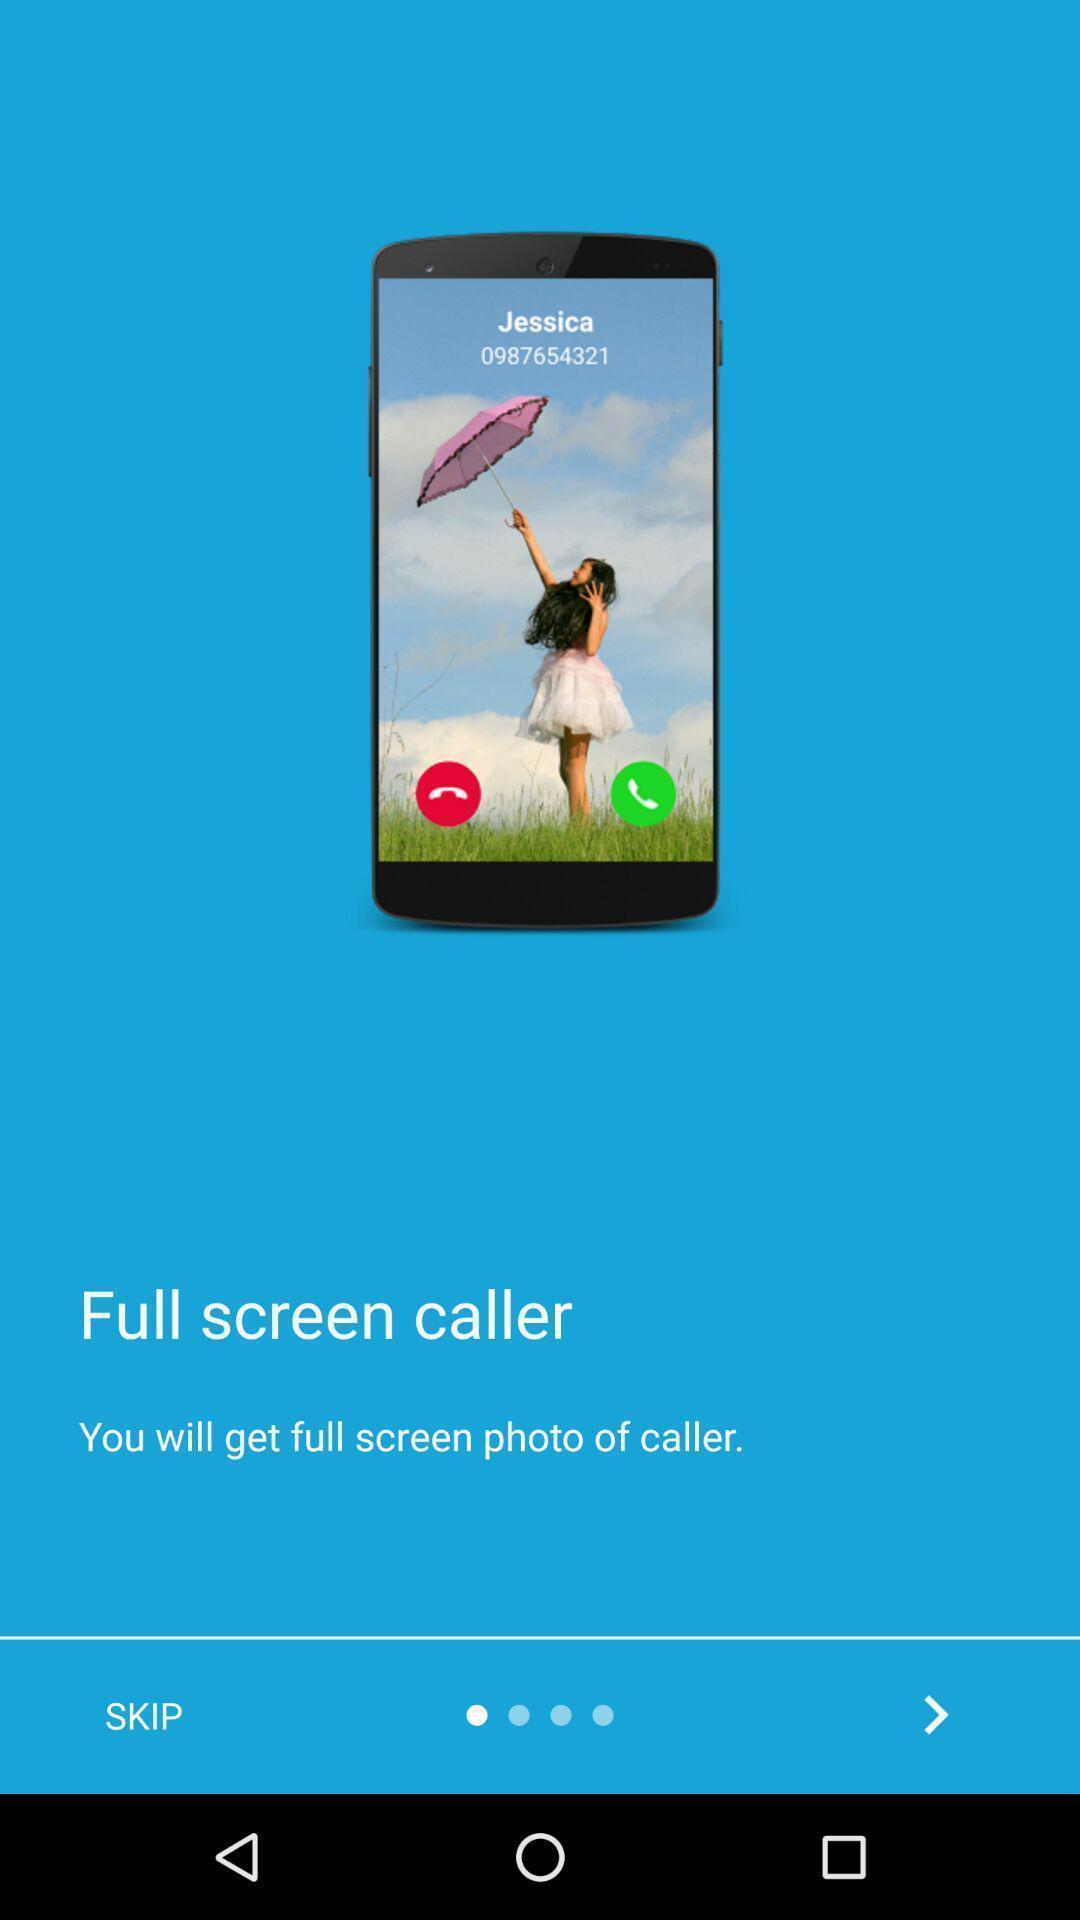Give me a summary of this screen capture. Welcome page. 